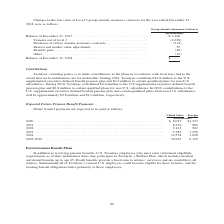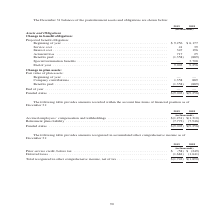According to Teradyne's financial document, What are the death benefits? provide a fixed sum to retirees’ survivors and are available to all retirees. The document states: "and dental benefits up to age 65. Death benefits provide a fixed sum to retirees’ survivors and are available to all retirees. Substantially all of Te..." Also, What was the Interest cost in 2019? According to the financial document, 347 (in thousands). The relevant text states: ",256 $ 6,177 Service cost . 41 39 Interest cost . 347 196 Actuarial loss . 717 25 Benefits paid . (1,358) (889) Special termination benefits . — 3,708..." Also, In which years is the December 31 balances of the postretirement assets and obligations are shown in the table? The document shows two values: 2019 and 2018. From the document: "2019 2018 2019 2018..." Additionally, In which year was Interest Cost larger? According to the financial document, 2019. The relevant text states: "2019 2018..." Also, can you calculate: What was the change in Service Cost from 2018 to 2019? Based on the calculation: 41-39, the result is 2 (in thousands). This is based on the information: "nning of year . $ 9,256 $ 6,177 Service cost . 41 39 Interest cost . 347 196 Actuarial loss . 717 25 Benefits paid . (1,358) (889) Special termination b eginning of year . $ 9,256 $ 6,177 Service cost..." The key data points involved are: 39, 41. Also, can you calculate: What was the percentage change in Service Cost from 2018 to 2019? To answer this question, I need to perform calculations using the financial data. The calculation is: (41-39)/39, which equals 5.13 (percentage). This is based on the information: "nning of year . $ 9,256 $ 6,177 Service cost . 41 39 Interest cost . 347 196 Actuarial loss . 717 25 Benefits paid . (1,358) (889) Special termination b eginning of year . $ 9,256 $ 6,177 Service cost..." The key data points involved are: 39, 41. 